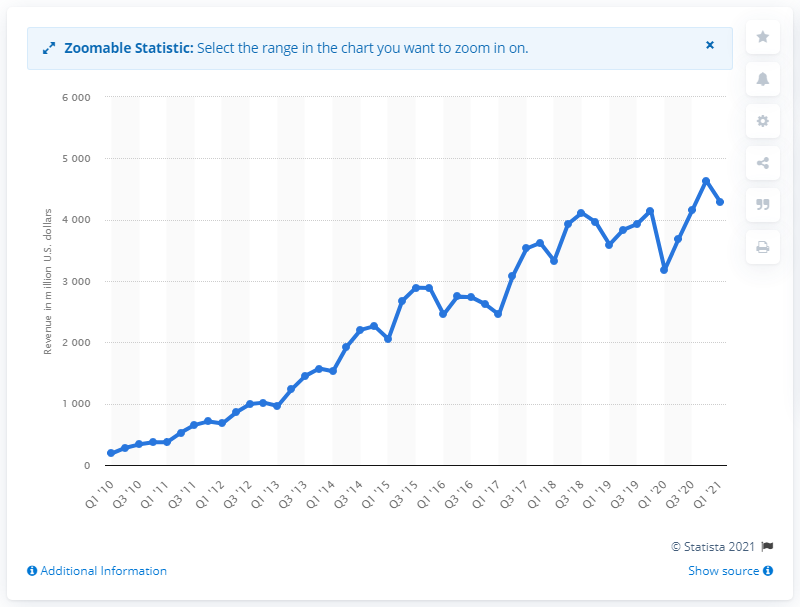Indicate a few pertinent items in this graphic. In the first quarter of 2021, Baidu's revenue was approximately 4294. 